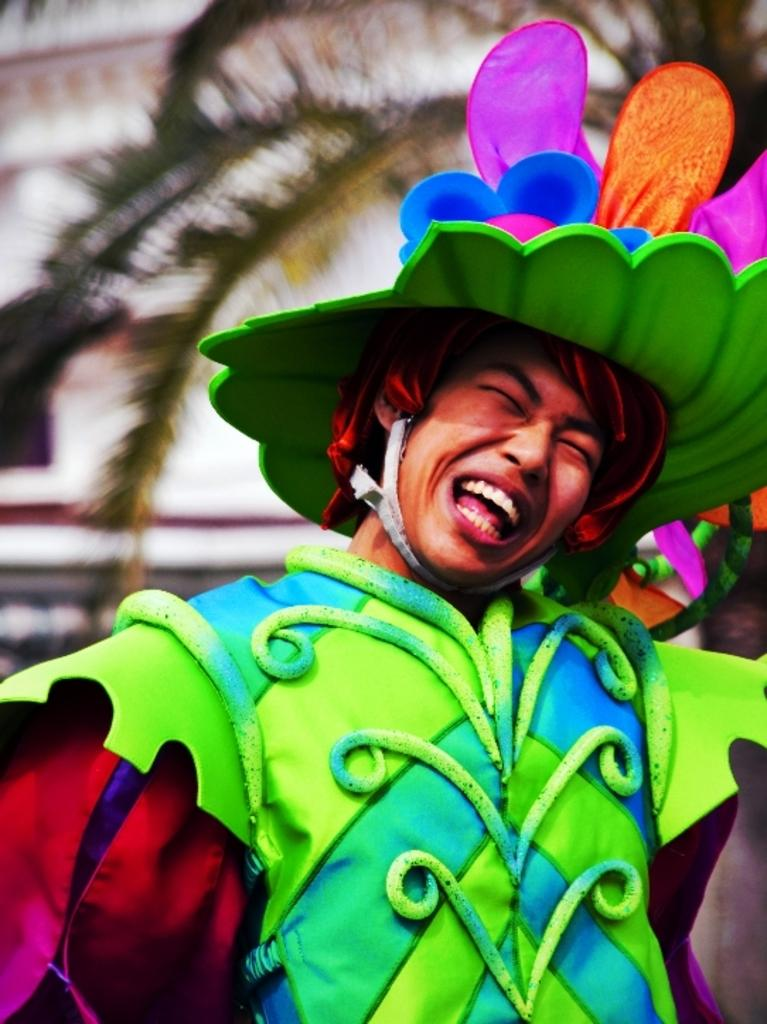Who is present in the image? There is a man in the image. What is the man doing in the image? The man is standing in the image. What is the man wearing in the image? The man is wearing a colorful dress and a colorful cap on his head. What can be seen in the background of the image? There is a tree and a building in the image. What is the man's father doing in the image? There is no mention of the man's father in the image, so we cannot answer this question. 